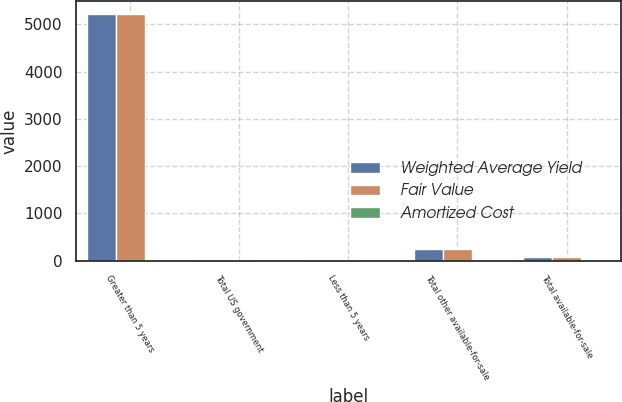Convert chart to OTSL. <chart><loc_0><loc_0><loc_500><loc_500><stacked_bar_chart><ecel><fcel>Greater than 5 years<fcel>Total US government<fcel>Less than 5 years<fcel>Total other available-for-sale<fcel>Total available-for-sale<nl><fcel>Weighted Average Yield<fcel>5207<fcel>19<fcel>19<fcel>252<fcel>89<nl><fcel>Fair Value<fcel>5222<fcel>19<fcel>19<fcel>254<fcel>89<nl><fcel>Amortized Cost<fcel>2.41<fcel>2.22<fcel>0.43<fcel>4.3<fcel>2.32<nl></chart> 